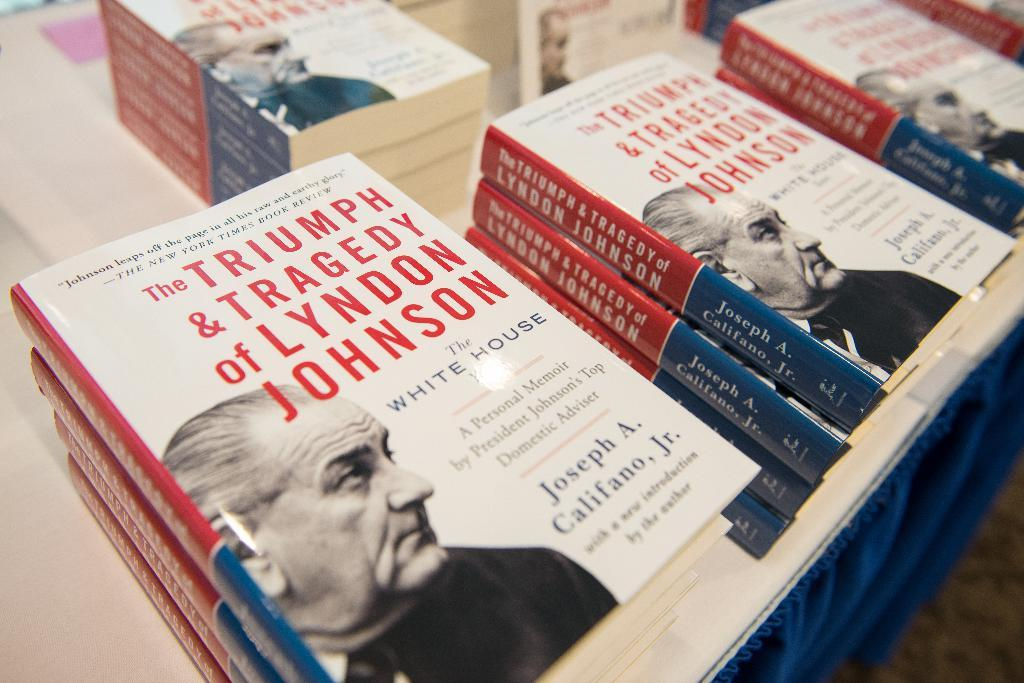<image>
Offer a succinct explanation of the picture presented. Several copies of a book about Lyndon Johnson are stacked on a table. 